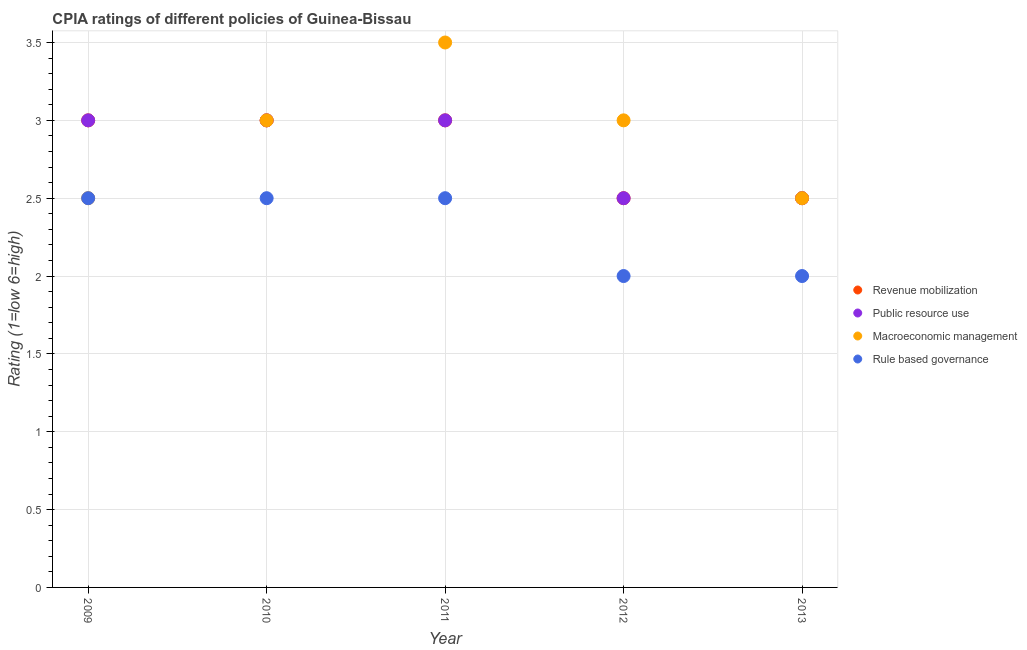How many different coloured dotlines are there?
Your response must be concise. 4. Across all years, what is the maximum cpia rating of rule based governance?
Ensure brevity in your answer.  2.5. In which year was the cpia rating of macroeconomic management maximum?
Offer a very short reply. 2011. What is the average cpia rating of revenue mobilization per year?
Offer a very short reply. 2.8. In the year 2012, what is the difference between the cpia rating of rule based governance and cpia rating of public resource use?
Give a very brief answer. -0.5. In how many years, is the cpia rating of revenue mobilization greater than 0.6?
Provide a short and direct response. 5. What is the ratio of the cpia rating of macroeconomic management in 2009 to that in 2013?
Give a very brief answer. 1. Is the difference between the cpia rating of revenue mobilization in 2009 and 2011 greater than the difference between the cpia rating of macroeconomic management in 2009 and 2011?
Provide a succinct answer. Yes. What is the difference between the highest and the second highest cpia rating of macroeconomic management?
Keep it short and to the point. 0.5. Is it the case that in every year, the sum of the cpia rating of revenue mobilization and cpia rating of public resource use is greater than the cpia rating of macroeconomic management?
Offer a very short reply. Yes. Is the cpia rating of macroeconomic management strictly less than the cpia rating of public resource use over the years?
Keep it short and to the point. No. Are the values on the major ticks of Y-axis written in scientific E-notation?
Your response must be concise. No. Does the graph contain grids?
Your response must be concise. Yes. Where does the legend appear in the graph?
Give a very brief answer. Center right. How many legend labels are there?
Offer a very short reply. 4. What is the title of the graph?
Keep it short and to the point. CPIA ratings of different policies of Guinea-Bissau. What is the label or title of the X-axis?
Keep it short and to the point. Year. What is the Rating (1=low 6=high) of Revenue mobilization in 2009?
Provide a short and direct response. 3. What is the Rating (1=low 6=high) in Public resource use in 2009?
Your answer should be compact. 3. What is the Rating (1=low 6=high) in Public resource use in 2010?
Offer a terse response. 3. What is the Rating (1=low 6=high) of Macroeconomic management in 2010?
Your answer should be compact. 3. What is the Rating (1=low 6=high) in Rule based governance in 2010?
Give a very brief answer. 2.5. What is the Rating (1=low 6=high) of Revenue mobilization in 2011?
Your answer should be compact. 3. What is the Rating (1=low 6=high) of Public resource use in 2012?
Ensure brevity in your answer.  2.5. What is the Rating (1=low 6=high) in Macroeconomic management in 2012?
Give a very brief answer. 3. What is the Rating (1=low 6=high) in Rule based governance in 2012?
Your answer should be very brief. 2. What is the Rating (1=low 6=high) in Public resource use in 2013?
Keep it short and to the point. 2.5. What is the Rating (1=low 6=high) of Macroeconomic management in 2013?
Keep it short and to the point. 2.5. Across all years, what is the maximum Rating (1=low 6=high) in Revenue mobilization?
Your response must be concise. 3. Across all years, what is the maximum Rating (1=low 6=high) in Public resource use?
Give a very brief answer. 3. Across all years, what is the maximum Rating (1=low 6=high) in Rule based governance?
Your answer should be compact. 2.5. What is the total Rating (1=low 6=high) of Revenue mobilization in the graph?
Ensure brevity in your answer.  14. What is the total Rating (1=low 6=high) of Rule based governance in the graph?
Your answer should be very brief. 11.5. What is the difference between the Rating (1=low 6=high) of Revenue mobilization in 2009 and that in 2010?
Provide a succinct answer. 0. What is the difference between the Rating (1=low 6=high) in Public resource use in 2009 and that in 2010?
Keep it short and to the point. 0. What is the difference between the Rating (1=low 6=high) of Revenue mobilization in 2009 and that in 2011?
Provide a short and direct response. 0. What is the difference between the Rating (1=low 6=high) in Macroeconomic management in 2009 and that in 2012?
Offer a terse response. -0.5. What is the difference between the Rating (1=low 6=high) in Rule based governance in 2009 and that in 2012?
Your answer should be very brief. 0.5. What is the difference between the Rating (1=low 6=high) in Revenue mobilization in 2009 and that in 2013?
Keep it short and to the point. 0.5. What is the difference between the Rating (1=low 6=high) of Public resource use in 2009 and that in 2013?
Give a very brief answer. 0.5. What is the difference between the Rating (1=low 6=high) of Revenue mobilization in 2010 and that in 2011?
Provide a short and direct response. 0. What is the difference between the Rating (1=low 6=high) in Public resource use in 2010 and that in 2012?
Keep it short and to the point. 0.5. What is the difference between the Rating (1=low 6=high) of Macroeconomic management in 2010 and that in 2012?
Offer a very short reply. 0. What is the difference between the Rating (1=low 6=high) in Rule based governance in 2010 and that in 2012?
Provide a succinct answer. 0.5. What is the difference between the Rating (1=low 6=high) of Public resource use in 2010 and that in 2013?
Offer a terse response. 0.5. What is the difference between the Rating (1=low 6=high) of Public resource use in 2011 and that in 2012?
Offer a very short reply. 0.5. What is the difference between the Rating (1=low 6=high) of Macroeconomic management in 2011 and that in 2013?
Keep it short and to the point. 1. What is the difference between the Rating (1=low 6=high) of Public resource use in 2012 and that in 2013?
Your response must be concise. 0. What is the difference between the Rating (1=low 6=high) of Macroeconomic management in 2012 and that in 2013?
Give a very brief answer. 0.5. What is the difference between the Rating (1=low 6=high) in Revenue mobilization in 2009 and the Rating (1=low 6=high) in Public resource use in 2010?
Provide a short and direct response. 0. What is the difference between the Rating (1=low 6=high) of Revenue mobilization in 2009 and the Rating (1=low 6=high) of Macroeconomic management in 2010?
Your response must be concise. 0. What is the difference between the Rating (1=low 6=high) in Revenue mobilization in 2009 and the Rating (1=low 6=high) in Rule based governance in 2010?
Provide a succinct answer. 0.5. What is the difference between the Rating (1=low 6=high) of Public resource use in 2009 and the Rating (1=low 6=high) of Rule based governance in 2010?
Make the answer very short. 0.5. What is the difference between the Rating (1=low 6=high) in Revenue mobilization in 2009 and the Rating (1=low 6=high) in Macroeconomic management in 2011?
Your answer should be very brief. -0.5. What is the difference between the Rating (1=low 6=high) in Revenue mobilization in 2009 and the Rating (1=low 6=high) in Rule based governance in 2011?
Provide a short and direct response. 0.5. What is the difference between the Rating (1=low 6=high) in Public resource use in 2009 and the Rating (1=low 6=high) in Macroeconomic management in 2011?
Give a very brief answer. -0.5. What is the difference between the Rating (1=low 6=high) of Macroeconomic management in 2009 and the Rating (1=low 6=high) of Rule based governance in 2011?
Your answer should be very brief. 0. What is the difference between the Rating (1=low 6=high) in Public resource use in 2009 and the Rating (1=low 6=high) in Rule based governance in 2012?
Provide a succinct answer. 1. What is the difference between the Rating (1=low 6=high) of Macroeconomic management in 2009 and the Rating (1=low 6=high) of Rule based governance in 2012?
Make the answer very short. 0.5. What is the difference between the Rating (1=low 6=high) of Revenue mobilization in 2009 and the Rating (1=low 6=high) of Public resource use in 2013?
Ensure brevity in your answer.  0.5. What is the difference between the Rating (1=low 6=high) in Revenue mobilization in 2009 and the Rating (1=low 6=high) in Macroeconomic management in 2013?
Provide a succinct answer. 0.5. What is the difference between the Rating (1=low 6=high) of Public resource use in 2009 and the Rating (1=low 6=high) of Macroeconomic management in 2013?
Give a very brief answer. 0.5. What is the difference between the Rating (1=low 6=high) in Macroeconomic management in 2009 and the Rating (1=low 6=high) in Rule based governance in 2013?
Keep it short and to the point. 0.5. What is the difference between the Rating (1=low 6=high) in Revenue mobilization in 2010 and the Rating (1=low 6=high) in Public resource use in 2011?
Keep it short and to the point. 0. What is the difference between the Rating (1=low 6=high) of Revenue mobilization in 2010 and the Rating (1=low 6=high) of Rule based governance in 2011?
Keep it short and to the point. 0.5. What is the difference between the Rating (1=low 6=high) in Macroeconomic management in 2010 and the Rating (1=low 6=high) in Rule based governance in 2011?
Offer a very short reply. 0.5. What is the difference between the Rating (1=low 6=high) in Revenue mobilization in 2010 and the Rating (1=low 6=high) in Public resource use in 2012?
Your response must be concise. 0.5. What is the difference between the Rating (1=low 6=high) in Revenue mobilization in 2010 and the Rating (1=low 6=high) in Macroeconomic management in 2012?
Offer a terse response. 0. What is the difference between the Rating (1=low 6=high) in Public resource use in 2010 and the Rating (1=low 6=high) in Rule based governance in 2012?
Make the answer very short. 1. What is the difference between the Rating (1=low 6=high) of Public resource use in 2010 and the Rating (1=low 6=high) of Rule based governance in 2013?
Your answer should be very brief. 1. What is the difference between the Rating (1=low 6=high) in Public resource use in 2011 and the Rating (1=low 6=high) in Macroeconomic management in 2012?
Your response must be concise. 0. What is the difference between the Rating (1=low 6=high) in Revenue mobilization in 2011 and the Rating (1=low 6=high) in Public resource use in 2013?
Provide a short and direct response. 0.5. What is the difference between the Rating (1=low 6=high) in Revenue mobilization in 2011 and the Rating (1=low 6=high) in Macroeconomic management in 2013?
Provide a succinct answer. 0.5. What is the difference between the Rating (1=low 6=high) of Revenue mobilization in 2011 and the Rating (1=low 6=high) of Rule based governance in 2013?
Ensure brevity in your answer.  1. What is the difference between the Rating (1=low 6=high) of Revenue mobilization in 2012 and the Rating (1=low 6=high) of Rule based governance in 2013?
Your answer should be very brief. 0.5. What is the difference between the Rating (1=low 6=high) in Public resource use in 2012 and the Rating (1=low 6=high) in Macroeconomic management in 2013?
Your answer should be compact. 0. What is the difference between the Rating (1=low 6=high) in Macroeconomic management in 2012 and the Rating (1=low 6=high) in Rule based governance in 2013?
Offer a terse response. 1. What is the average Rating (1=low 6=high) in Macroeconomic management per year?
Provide a short and direct response. 2.9. What is the average Rating (1=low 6=high) in Rule based governance per year?
Ensure brevity in your answer.  2.3. In the year 2009, what is the difference between the Rating (1=low 6=high) in Revenue mobilization and Rating (1=low 6=high) in Public resource use?
Provide a short and direct response. 0. In the year 2009, what is the difference between the Rating (1=low 6=high) of Macroeconomic management and Rating (1=low 6=high) of Rule based governance?
Make the answer very short. 0. In the year 2010, what is the difference between the Rating (1=low 6=high) of Revenue mobilization and Rating (1=low 6=high) of Public resource use?
Ensure brevity in your answer.  0. In the year 2010, what is the difference between the Rating (1=low 6=high) of Revenue mobilization and Rating (1=low 6=high) of Macroeconomic management?
Your answer should be very brief. 0. In the year 2011, what is the difference between the Rating (1=low 6=high) in Revenue mobilization and Rating (1=low 6=high) in Public resource use?
Provide a short and direct response. 0. In the year 2011, what is the difference between the Rating (1=low 6=high) in Revenue mobilization and Rating (1=low 6=high) in Rule based governance?
Your response must be concise. 0.5. In the year 2011, what is the difference between the Rating (1=low 6=high) of Public resource use and Rating (1=low 6=high) of Macroeconomic management?
Provide a succinct answer. -0.5. In the year 2011, what is the difference between the Rating (1=low 6=high) in Public resource use and Rating (1=low 6=high) in Rule based governance?
Give a very brief answer. 0.5. In the year 2011, what is the difference between the Rating (1=low 6=high) of Macroeconomic management and Rating (1=low 6=high) of Rule based governance?
Your answer should be very brief. 1. In the year 2012, what is the difference between the Rating (1=low 6=high) in Revenue mobilization and Rating (1=low 6=high) in Rule based governance?
Keep it short and to the point. 0.5. In the year 2013, what is the difference between the Rating (1=low 6=high) of Revenue mobilization and Rating (1=low 6=high) of Public resource use?
Keep it short and to the point. 0. In the year 2013, what is the difference between the Rating (1=low 6=high) of Public resource use and Rating (1=low 6=high) of Macroeconomic management?
Ensure brevity in your answer.  0. In the year 2013, what is the difference between the Rating (1=low 6=high) of Public resource use and Rating (1=low 6=high) of Rule based governance?
Your answer should be compact. 0.5. What is the ratio of the Rating (1=low 6=high) of Revenue mobilization in 2009 to that in 2010?
Provide a short and direct response. 1. What is the ratio of the Rating (1=low 6=high) of Rule based governance in 2009 to that in 2011?
Provide a succinct answer. 1. What is the ratio of the Rating (1=low 6=high) of Revenue mobilization in 2009 to that in 2012?
Your answer should be very brief. 1.2. What is the ratio of the Rating (1=low 6=high) of Public resource use in 2009 to that in 2012?
Make the answer very short. 1.2. What is the ratio of the Rating (1=low 6=high) of Rule based governance in 2009 to that in 2012?
Provide a succinct answer. 1.25. What is the ratio of the Rating (1=low 6=high) in Revenue mobilization in 2009 to that in 2013?
Keep it short and to the point. 1.2. What is the ratio of the Rating (1=low 6=high) in Public resource use in 2009 to that in 2013?
Your response must be concise. 1.2. What is the ratio of the Rating (1=low 6=high) in Macroeconomic management in 2009 to that in 2013?
Keep it short and to the point. 1. What is the ratio of the Rating (1=low 6=high) in Revenue mobilization in 2010 to that in 2011?
Provide a succinct answer. 1. What is the ratio of the Rating (1=low 6=high) of Rule based governance in 2010 to that in 2011?
Make the answer very short. 1. What is the ratio of the Rating (1=low 6=high) of Revenue mobilization in 2010 to that in 2012?
Provide a succinct answer. 1.2. What is the ratio of the Rating (1=low 6=high) of Public resource use in 2010 to that in 2012?
Offer a very short reply. 1.2. What is the ratio of the Rating (1=low 6=high) in Macroeconomic management in 2010 to that in 2012?
Ensure brevity in your answer.  1. What is the ratio of the Rating (1=low 6=high) in Revenue mobilization in 2010 to that in 2013?
Keep it short and to the point. 1.2. What is the ratio of the Rating (1=low 6=high) in Revenue mobilization in 2011 to that in 2012?
Your response must be concise. 1.2. What is the ratio of the Rating (1=low 6=high) of Public resource use in 2011 to that in 2013?
Keep it short and to the point. 1.2. What is the ratio of the Rating (1=low 6=high) of Macroeconomic management in 2011 to that in 2013?
Offer a very short reply. 1.4. What is the ratio of the Rating (1=low 6=high) of Rule based governance in 2011 to that in 2013?
Make the answer very short. 1.25. What is the ratio of the Rating (1=low 6=high) of Revenue mobilization in 2012 to that in 2013?
Your answer should be compact. 1. What is the ratio of the Rating (1=low 6=high) in Macroeconomic management in 2012 to that in 2013?
Your answer should be compact. 1.2. What is the ratio of the Rating (1=low 6=high) of Rule based governance in 2012 to that in 2013?
Give a very brief answer. 1. What is the difference between the highest and the second highest Rating (1=low 6=high) of Revenue mobilization?
Your answer should be compact. 0. What is the difference between the highest and the second highest Rating (1=low 6=high) of Public resource use?
Keep it short and to the point. 0. What is the difference between the highest and the second highest Rating (1=low 6=high) in Macroeconomic management?
Provide a short and direct response. 0.5. What is the difference between the highest and the lowest Rating (1=low 6=high) of Revenue mobilization?
Your answer should be very brief. 0.5. What is the difference between the highest and the lowest Rating (1=low 6=high) in Macroeconomic management?
Offer a terse response. 1. What is the difference between the highest and the lowest Rating (1=low 6=high) of Rule based governance?
Offer a very short reply. 0.5. 